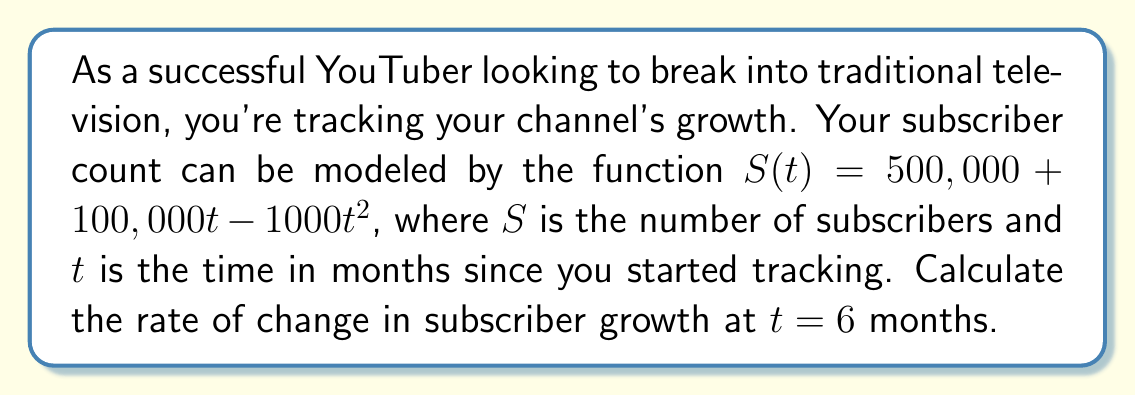Provide a solution to this math problem. To solve this problem, we need to find the derivative of the subscriber function $S(t)$ and then evaluate it at $t = 6$ months. This will give us the instantaneous rate of change in subscriber growth at that point in time.

1. Given function: $S(t) = 500,000 + 100,000t - 1000t^2$

2. To find the rate of change, we need to calculate $\frac{dS}{dt}$:
   $$\frac{dS}{dt} = \frac{d}{dt}(500,000 + 100,000t - 1000t^2)$$

3. Using the power rule and constant rule of differentiation:
   $$\frac{dS}{dt} = 0 + 100,000 - 2000t$$

4. Simplify:
   $$\frac{dS}{dt} = 100,000 - 2000t$$

5. Now, we evaluate this derivative at $t = 6$ months:
   $$\frac{dS}{dt}\bigg|_{t=6} = 100,000 - 2000(6)$$

6. Calculate:
   $$\frac{dS}{dt}\bigg|_{t=6} = 100,000 - 12,000 = 88,000$$

This result represents the instantaneous rate of change in subscriber growth at 6 months, measured in subscribers per month.
Answer: The rate of change in subscriber growth at $t = 6$ months is 88,000 subscribers per month. 